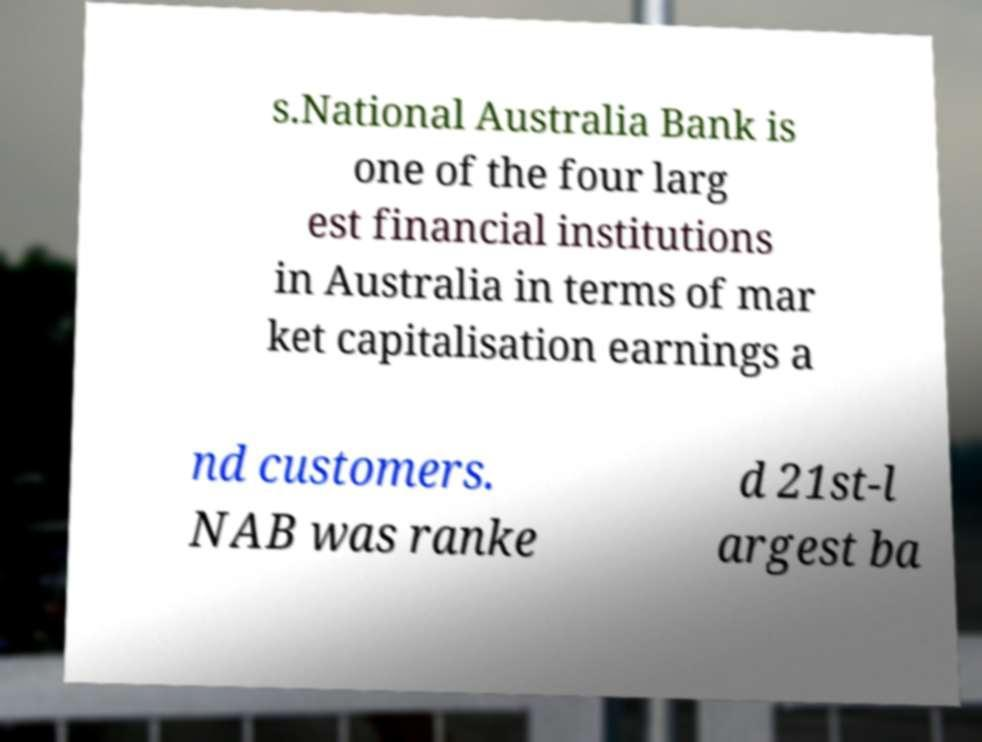What messages or text are displayed in this image? I need them in a readable, typed format. s.National Australia Bank is one of the four larg est financial institutions in Australia in terms of mar ket capitalisation earnings a nd customers. NAB was ranke d 21st-l argest ba 